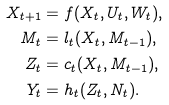<formula> <loc_0><loc_0><loc_500><loc_500>X _ { t + 1 } & = f ( X _ { t } , U _ { t } , W _ { t } ) , \\ M _ { t } & = l _ { t } ( X _ { t } , M _ { t - 1 } ) , \\ Z _ { t } & = c _ { t } ( X _ { t } , M _ { t - 1 } ) , \\ Y _ { t } & = h _ { t } ( Z _ { t } , N _ { t } ) .</formula> 